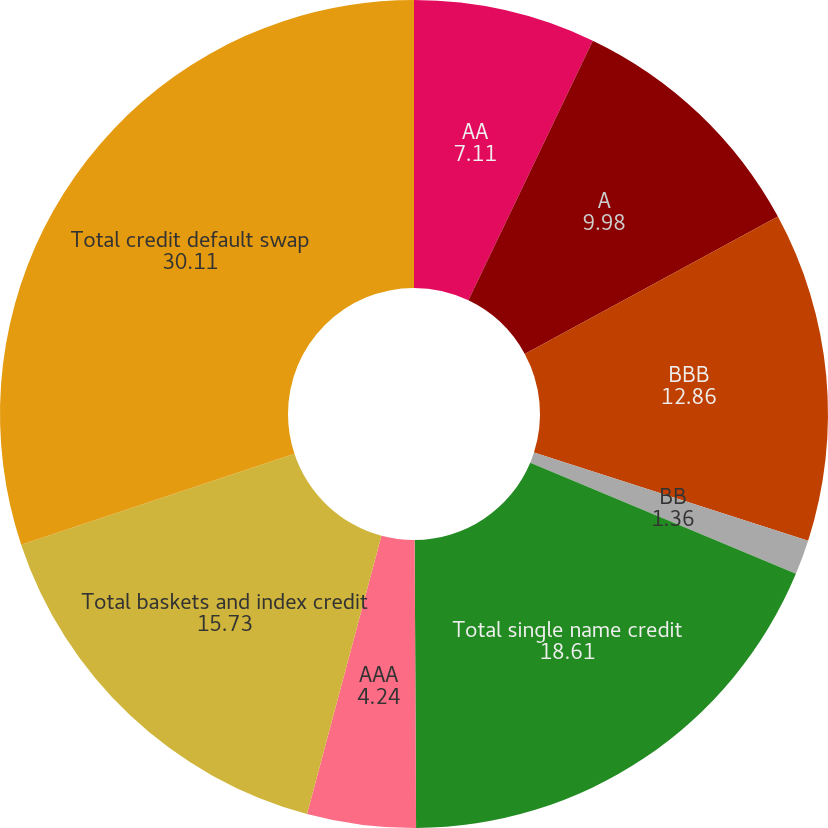Convert chart. <chart><loc_0><loc_0><loc_500><loc_500><pie_chart><fcel>AA<fcel>A<fcel>BBB<fcel>BB<fcel>Total single name credit<fcel>AAA<fcel>Total baskets and index credit<fcel>Total credit default swap<nl><fcel>7.11%<fcel>9.98%<fcel>12.86%<fcel>1.36%<fcel>18.61%<fcel>4.24%<fcel>15.73%<fcel>30.11%<nl></chart> 